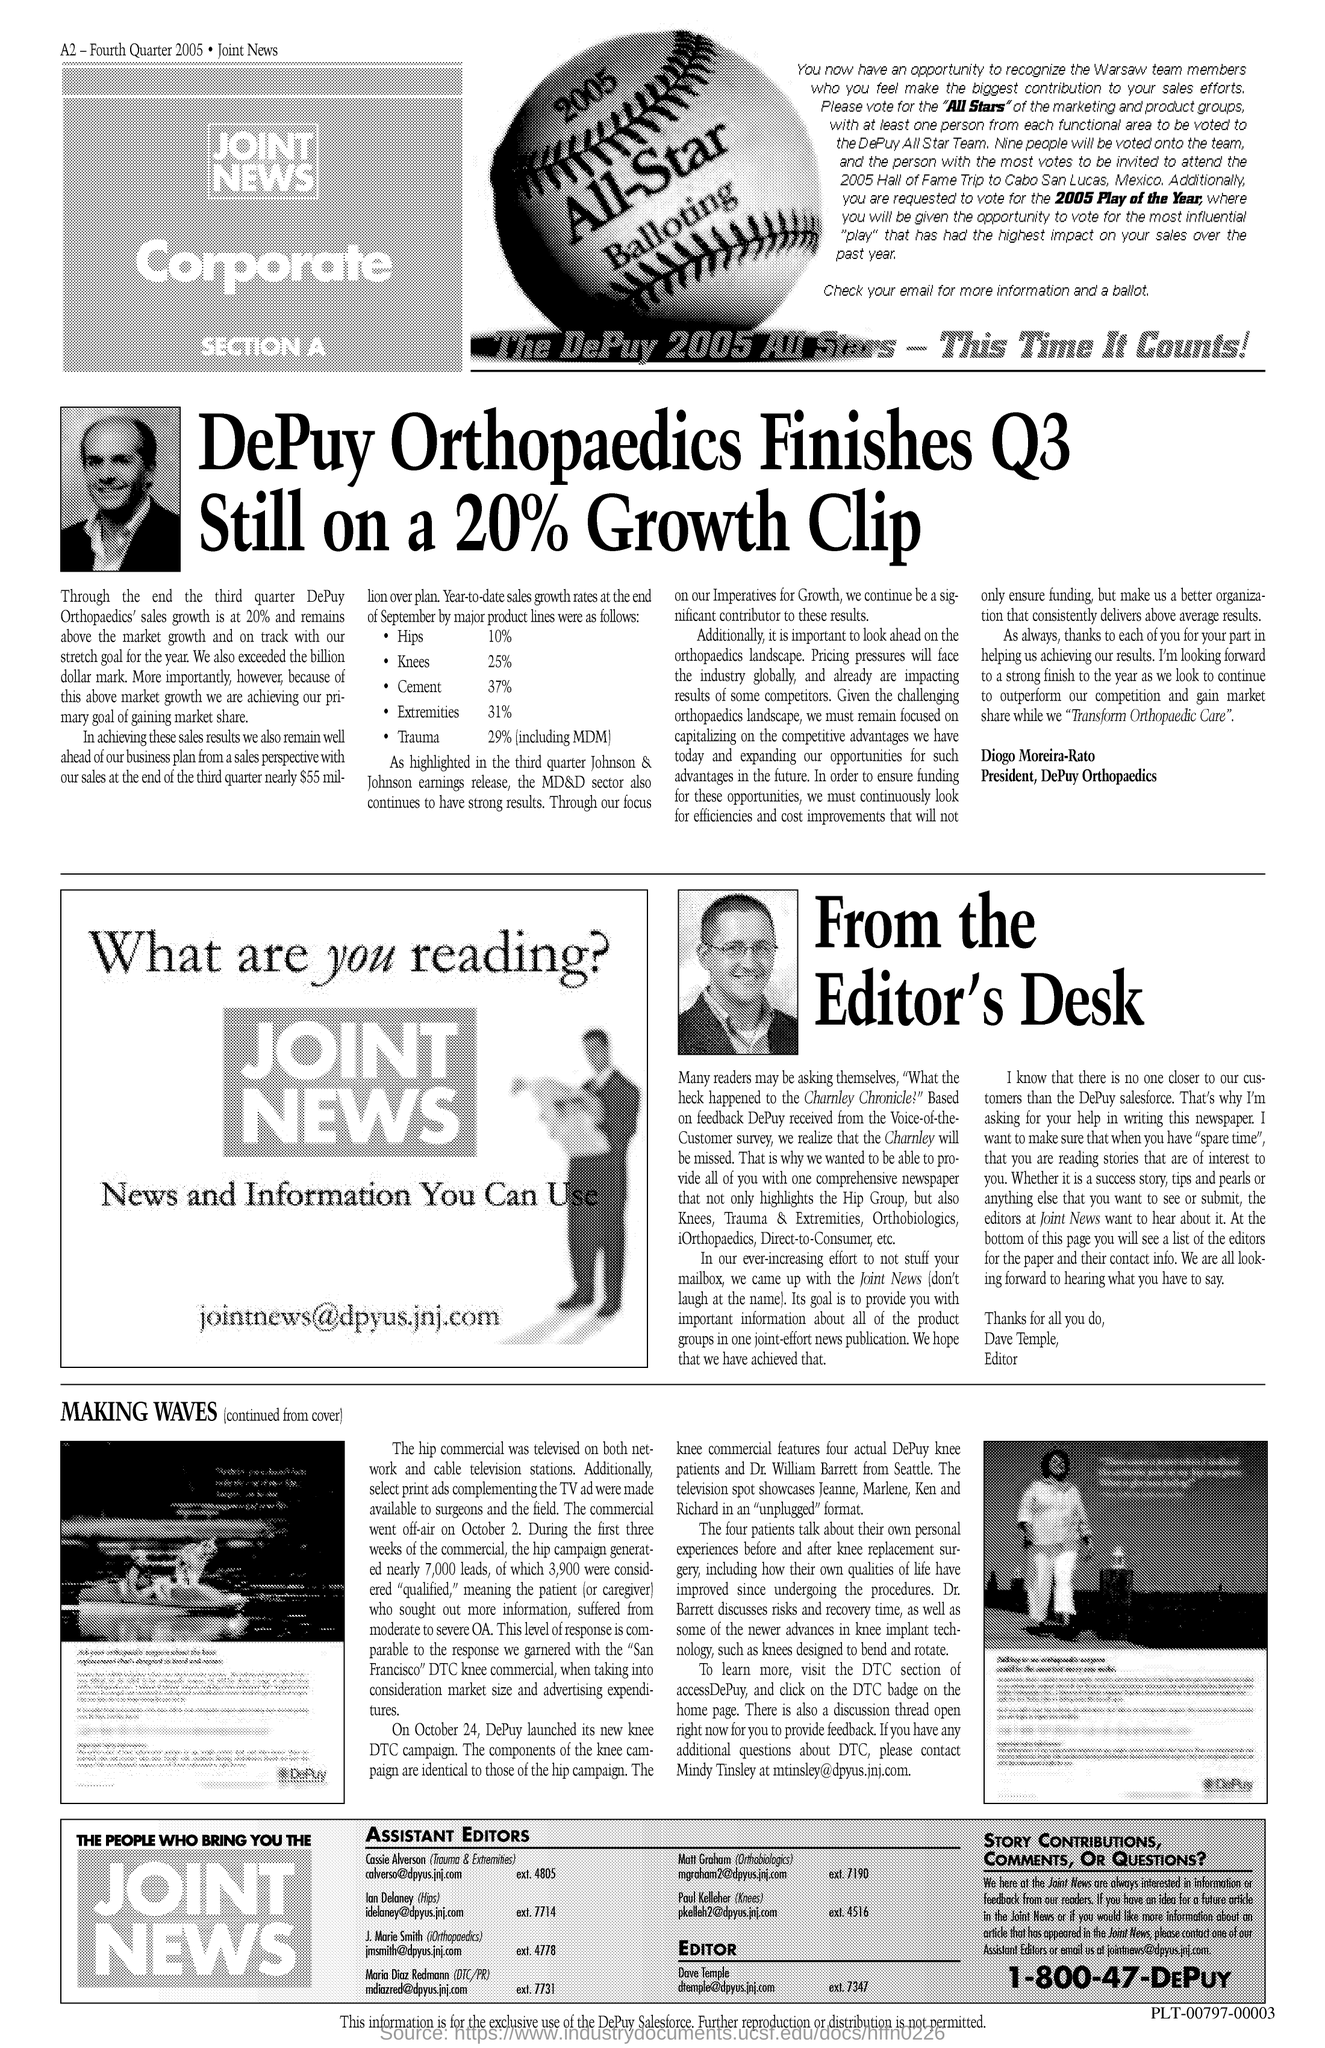Who is the president of DePuy Orthopaedics?
Provide a short and direct response. Diogo Moreira-Rato. 